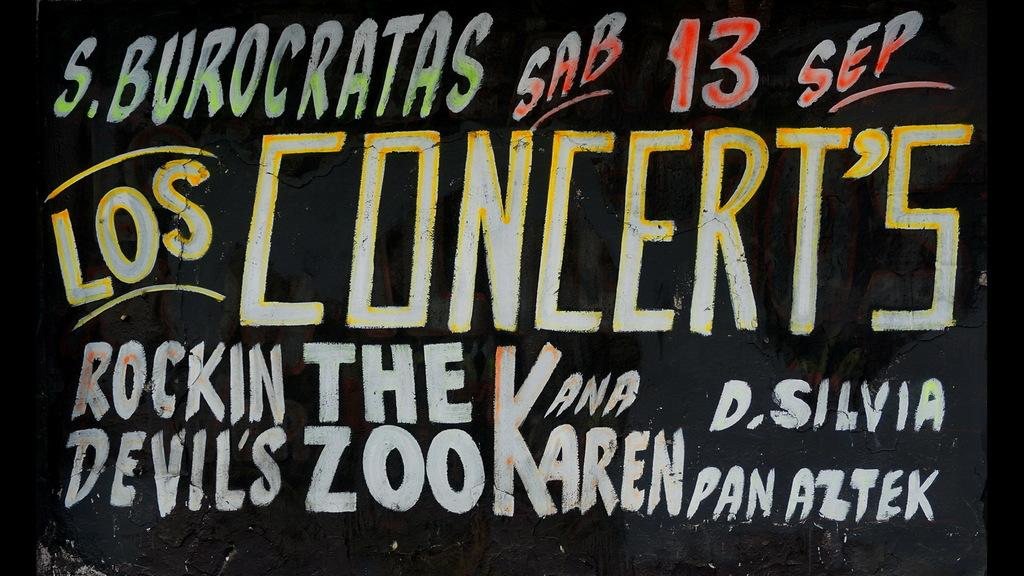What is the main object in the image? There is a blackboard in the image. What is on the blackboard? Something is written on the blackboard. What type of clouds can be seen in the image? There are no clouds present in the image, as it only features a blackboard with writing on it. 